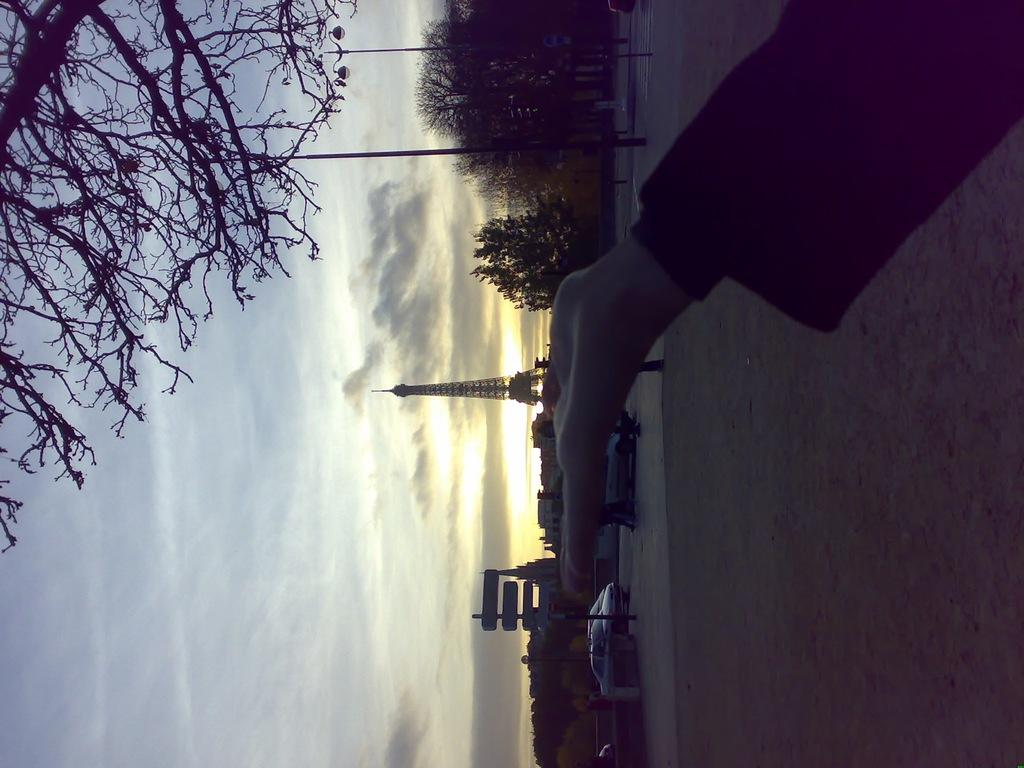What can be seen in the image that belongs to a person? There is a person's hand in the image. What is visible beneath the person's hand? The ground is visible in the image. What can be seen in the distance behind the person? There are vehicles, poles, trees, buildings, boards, and a tower visible in the background of the image. What is visible in the sky in the image? The sky is visible in the background of the image, and clouds are present. What type of pen is being used by the person in the image? There is no pen visible in the image; only a person's hand is shown. What is the person's fear in the image? There is no indication of fear in the image; it only shows a person's hand and the surrounding environment. 